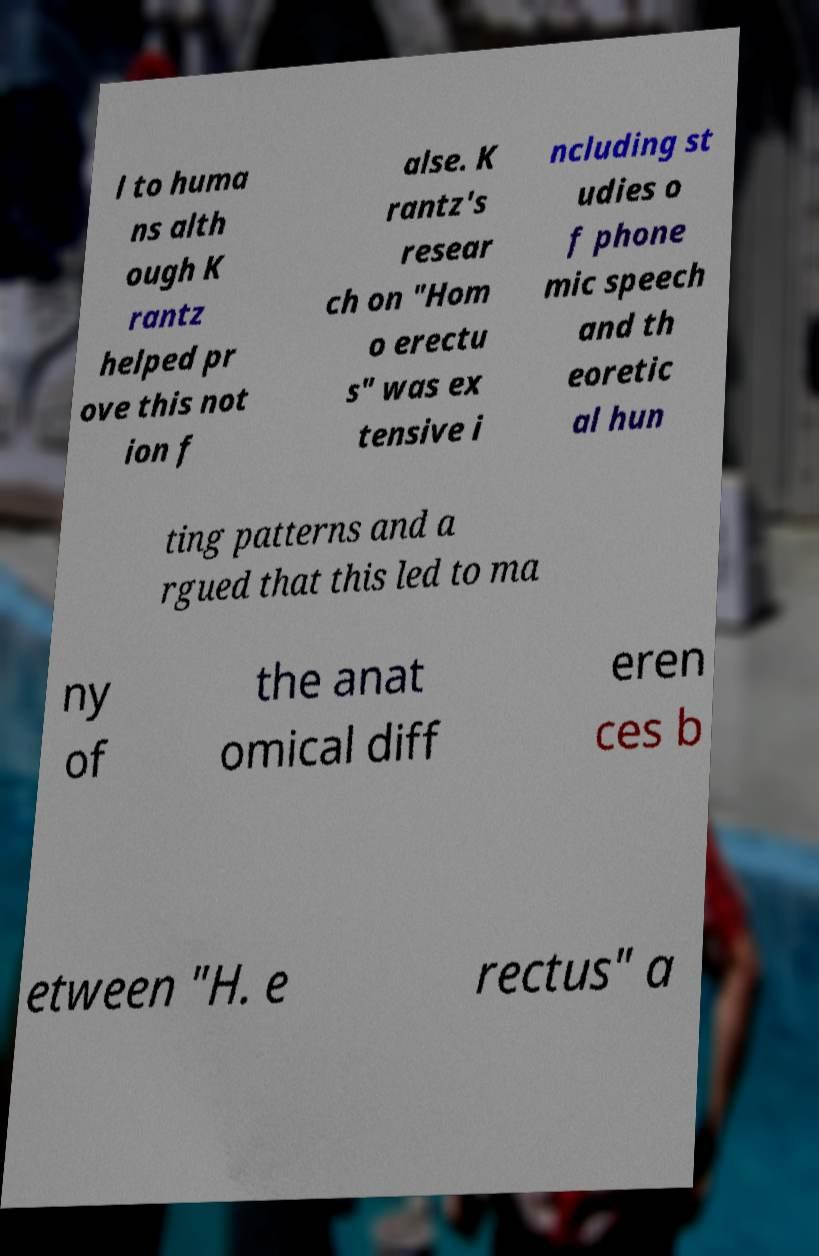For documentation purposes, I need the text within this image transcribed. Could you provide that? l to huma ns alth ough K rantz helped pr ove this not ion f alse. K rantz's resear ch on "Hom o erectu s" was ex tensive i ncluding st udies o f phone mic speech and th eoretic al hun ting patterns and a rgued that this led to ma ny of the anat omical diff eren ces b etween "H. e rectus" a 